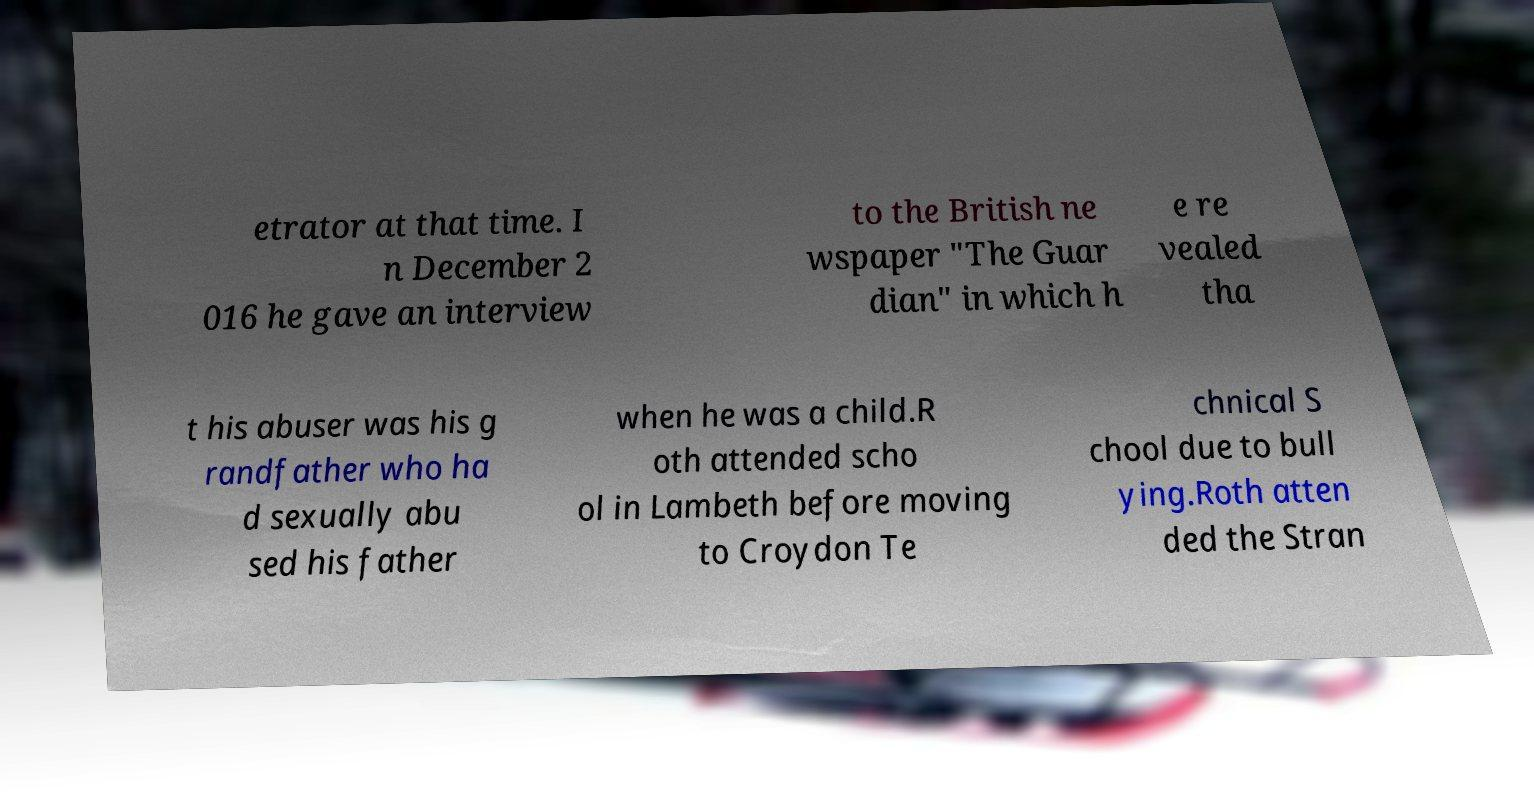Please read and relay the text visible in this image. What does it say? etrator at that time. I n December 2 016 he gave an interview to the British ne wspaper "The Guar dian" in which h e re vealed tha t his abuser was his g randfather who ha d sexually abu sed his father when he was a child.R oth attended scho ol in Lambeth before moving to Croydon Te chnical S chool due to bull ying.Roth atten ded the Stran 